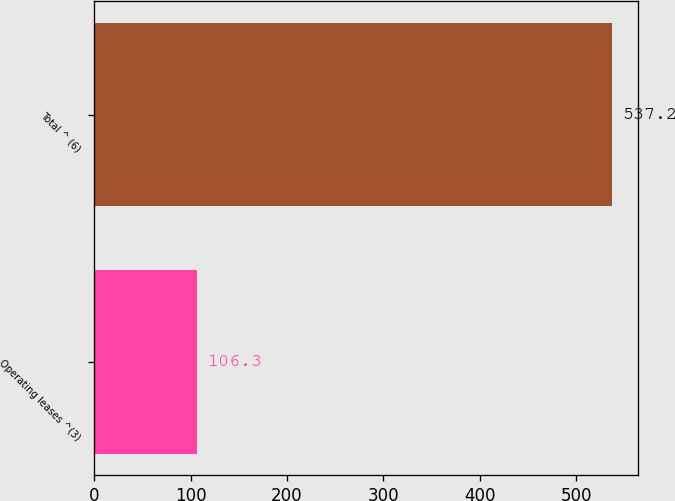Convert chart. <chart><loc_0><loc_0><loc_500><loc_500><bar_chart><fcel>Operating leases ^(3)<fcel>Total ^ (6)<nl><fcel>106.3<fcel>537.2<nl></chart> 